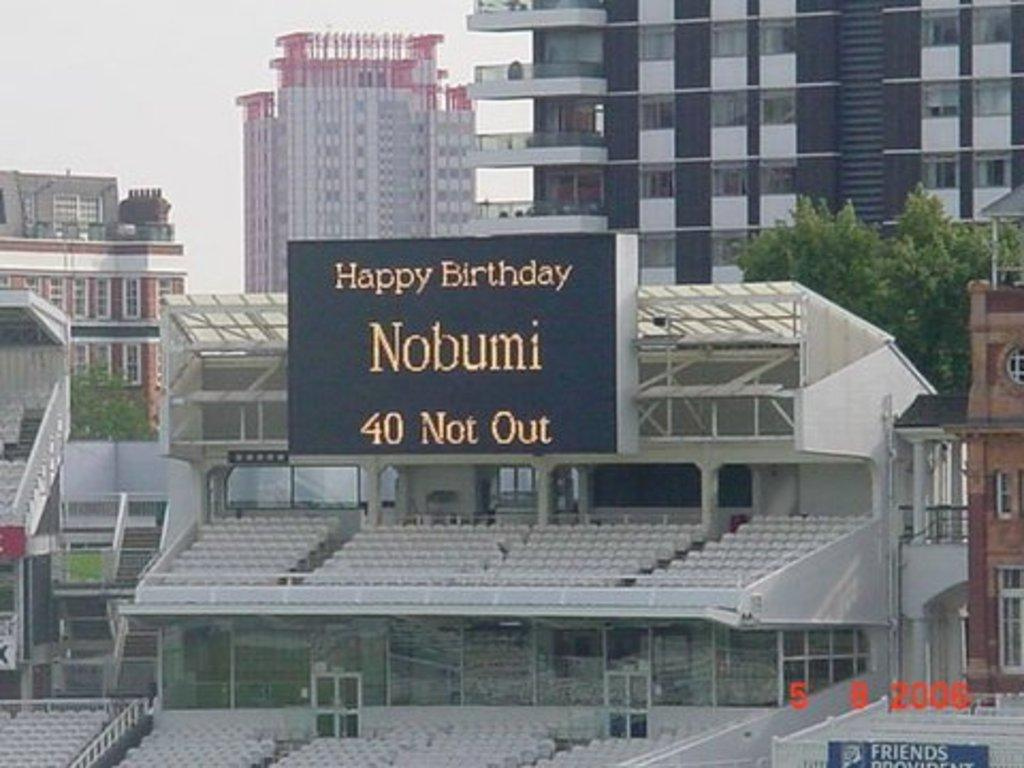Provide a one-sentence caption for the provided image. a sign with the word Nobumi on it. 